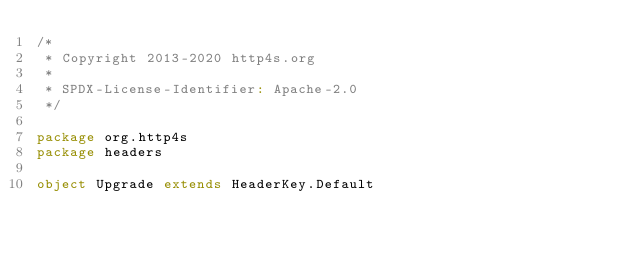Convert code to text. <code><loc_0><loc_0><loc_500><loc_500><_Scala_>/*
 * Copyright 2013-2020 http4s.org
 *
 * SPDX-License-Identifier: Apache-2.0
 */

package org.http4s
package headers

object Upgrade extends HeaderKey.Default
</code> 